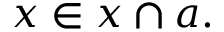<formula> <loc_0><loc_0><loc_500><loc_500>x \in x \cap a .</formula> 